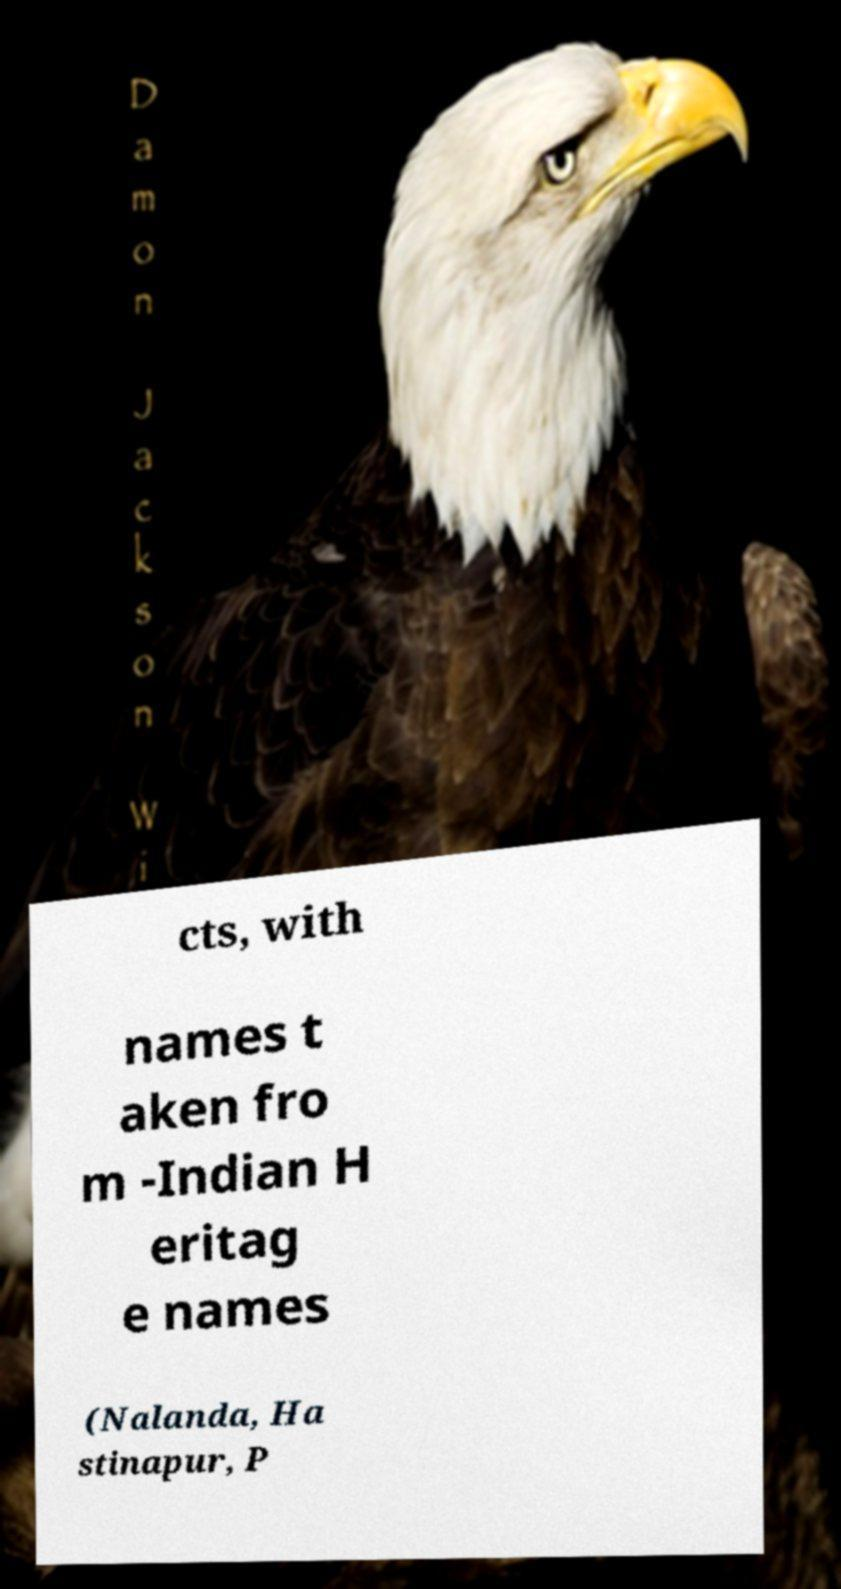Please identify and transcribe the text found in this image. cts, with names t aken fro m -Indian H eritag e names (Nalanda, Ha stinapur, P 